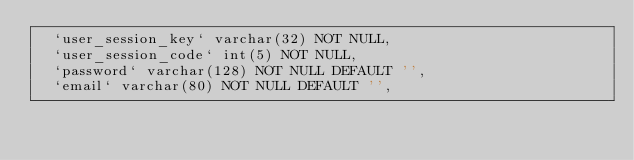Convert code to text. <code><loc_0><loc_0><loc_500><loc_500><_SQL_>  `user_session_key` varchar(32) NOT NULL,
  `user_session_code` int(5) NOT NULL,
  `password` varchar(128) NOT NULL DEFAULT '',
  `email` varchar(80) NOT NULL DEFAULT '',</code> 